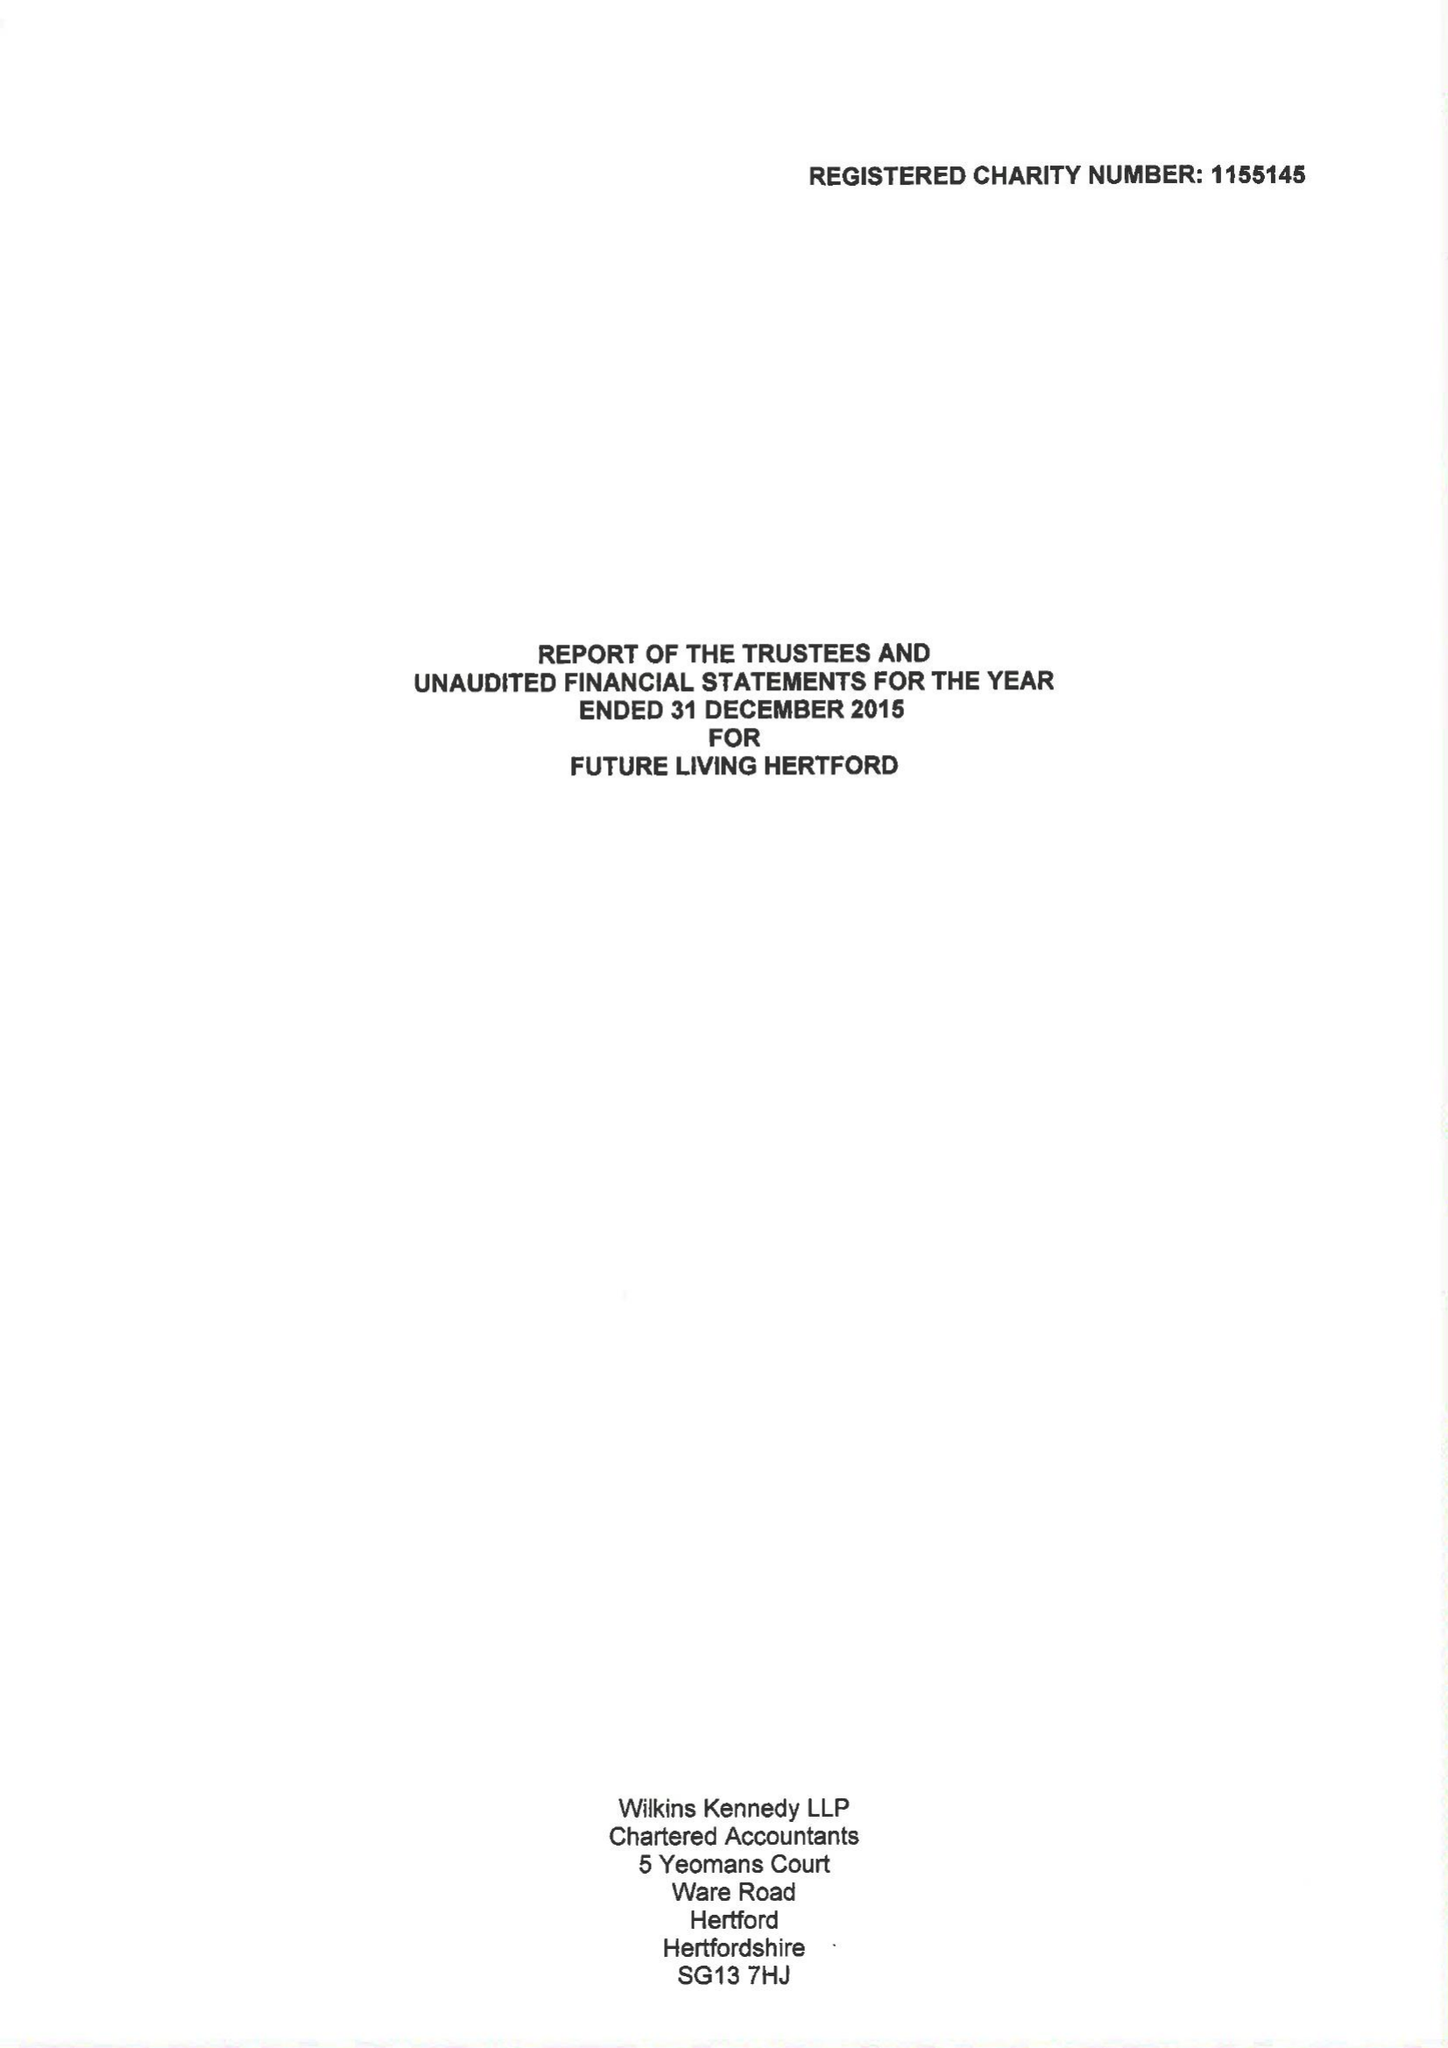What is the value for the address__street_line?
Answer the question using a single word or phrase. 43 COWBRIDGE 